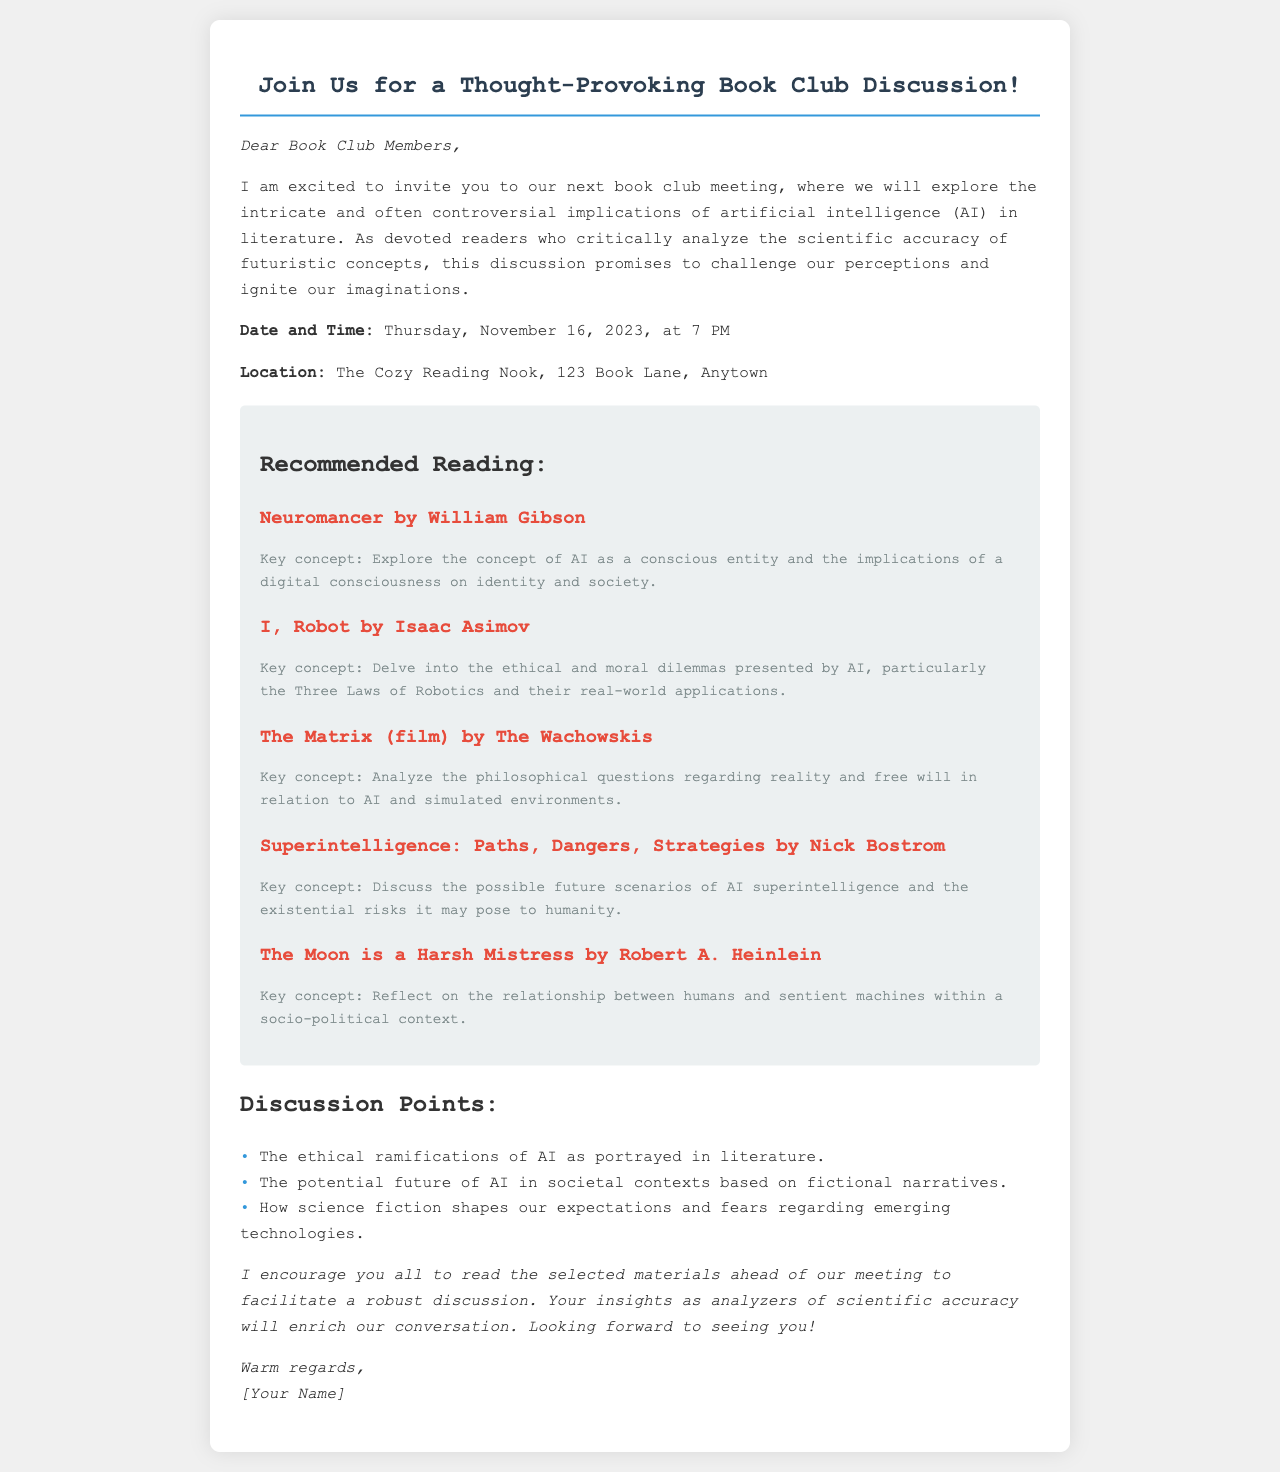What is the date and time of the book club meeting? The date and time are explicitly stated in the document.
Answer: Thursday, November 16, 2023, at 7 PM Where is the book club meeting located? The location of the meeting is provided in the invitation.
Answer: The Cozy Reading Nook, 123 Book Lane, Anytown Which book by Isaac Asimov is recommended for reading? The document lists several books and authors, specifying the title and author for Isaac Asimov.
Answer: I, Robot What key concept is associated with "Neuromancer" by William Gibson? Each reading item includes a key concept, and this pertains to AI and identity.
Answer: AI as a conscious entity Which film is suggested for discussion? A film is mentioned as part of the recommended reading, which indicates its medium.
Answer: The Matrix What are the Three Laws of Robotics? The Three Laws are referenced in the context of ethical dilemmas concerning AI in literature.
Answer: Not explicitly stated in the document What is one discussion point for the book club meeting? The document provides a list of discussion points that reflect the themes of ethics and society in relation to AI.
Answer: The ethical ramifications of AI as portrayed in literature Who is the sender of the letter? The closing section of the document reveals the identity of the person sending the invitation.
Answer: [Your Name] 